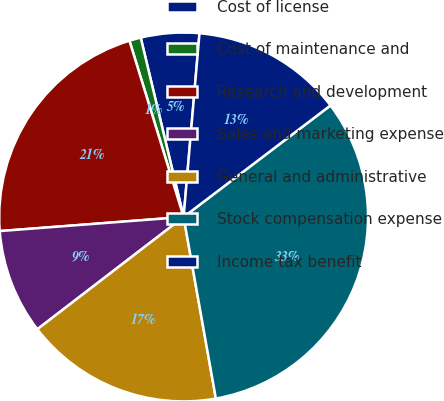Convert chart. <chart><loc_0><loc_0><loc_500><loc_500><pie_chart><fcel>Cost of license<fcel>Cost of maintenance and<fcel>Research and development<fcel>Sales and marketing expense<fcel>General and administrative<fcel>Stock compensation expense<fcel>Income tax benefit<nl><fcel>5.11%<fcel>1.01%<fcel>21.47%<fcel>9.2%<fcel>17.38%<fcel>32.54%<fcel>13.29%<nl></chart> 